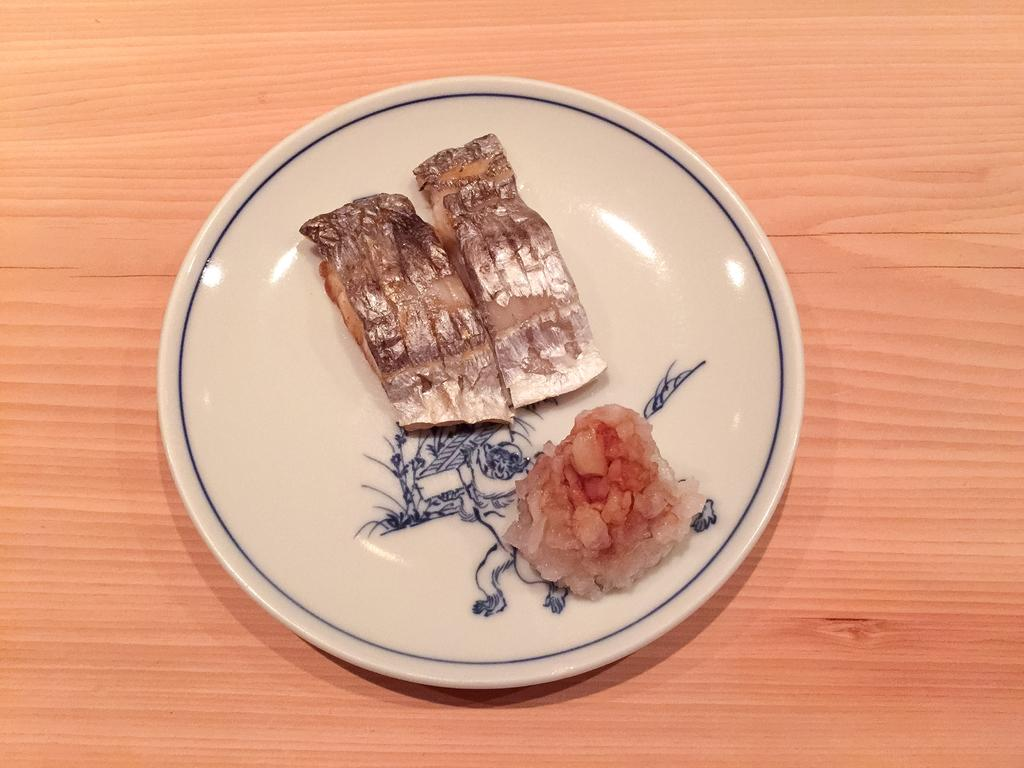What type of items can be seen in the image? There are eatables in the image. How are the eatables arranged in the image? The eatables are placed on a white plate. Where is the plate located in the image? The plate is placed on a table. How does the pan help in the consumption of the eatables in the image? There is no pan present in the image, so it cannot help in the consumption of the eatables. 